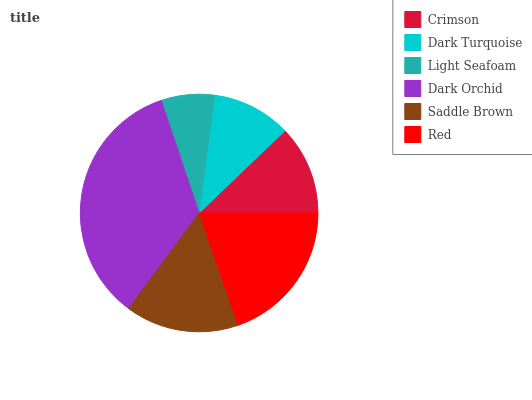Is Light Seafoam the minimum?
Answer yes or no. Yes. Is Dark Orchid the maximum?
Answer yes or no. Yes. Is Dark Turquoise the minimum?
Answer yes or no. No. Is Dark Turquoise the maximum?
Answer yes or no. No. Is Crimson greater than Dark Turquoise?
Answer yes or no. Yes. Is Dark Turquoise less than Crimson?
Answer yes or no. Yes. Is Dark Turquoise greater than Crimson?
Answer yes or no. No. Is Crimson less than Dark Turquoise?
Answer yes or no. No. Is Saddle Brown the high median?
Answer yes or no. Yes. Is Crimson the low median?
Answer yes or no. Yes. Is Light Seafoam the high median?
Answer yes or no. No. Is Saddle Brown the low median?
Answer yes or no. No. 